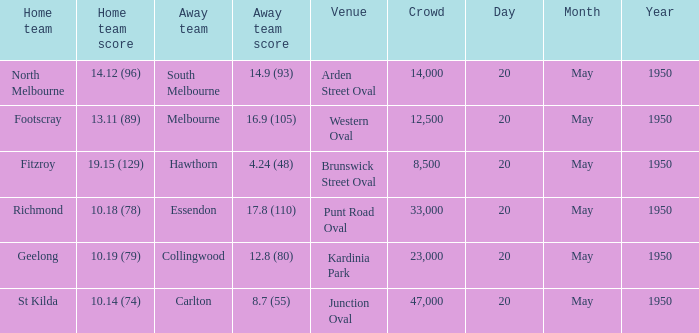What was the score for the visiting team that competed against richmond and had an audience of more than 12,500? 17.8 (110). 